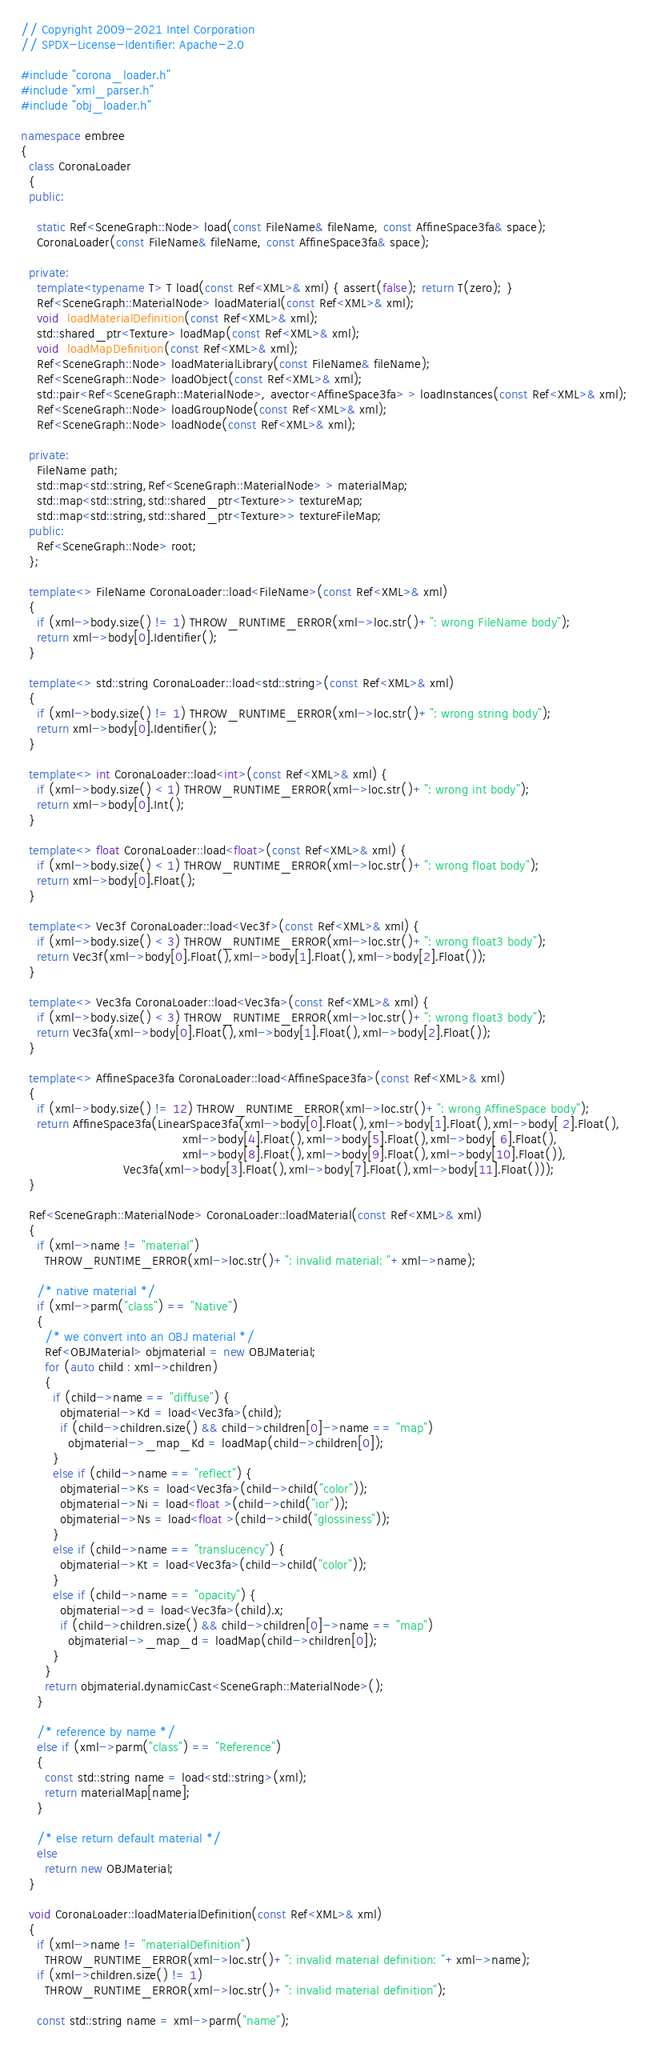<code> <loc_0><loc_0><loc_500><loc_500><_C++_>// Copyright 2009-2021 Intel Corporation
// SPDX-License-Identifier: Apache-2.0

#include "corona_loader.h"
#include "xml_parser.h"
#include "obj_loader.h"

namespace embree
{
  class CoronaLoader
  {
  public:

    static Ref<SceneGraph::Node> load(const FileName& fileName, const AffineSpace3fa& space);
    CoronaLoader(const FileName& fileName, const AffineSpace3fa& space);

  private:
    template<typename T> T load(const Ref<XML>& xml) { assert(false); return T(zero); }
    Ref<SceneGraph::MaterialNode> loadMaterial(const Ref<XML>& xml);
    void  loadMaterialDefinition(const Ref<XML>& xml);
    std::shared_ptr<Texture> loadMap(const Ref<XML>& xml);
    void  loadMapDefinition(const Ref<XML>& xml);
    Ref<SceneGraph::Node> loadMaterialLibrary(const FileName& fileName);
    Ref<SceneGraph::Node> loadObject(const Ref<XML>& xml);
    std::pair<Ref<SceneGraph::MaterialNode>, avector<AffineSpace3fa> > loadInstances(const Ref<XML>& xml);
    Ref<SceneGraph::Node> loadGroupNode(const Ref<XML>& xml);
    Ref<SceneGraph::Node> loadNode(const Ref<XML>& xml);

  private:
    FileName path; 
    std::map<std::string,Ref<SceneGraph::MaterialNode> > materialMap; 
    std::map<std::string,std::shared_ptr<Texture>> textureMap; 
    std::map<std::string,std::shared_ptr<Texture>> textureFileMap; 
  public:
    Ref<SceneGraph::Node> root;
  };

  template<> FileName CoronaLoader::load<FileName>(const Ref<XML>& xml) 
  {
    if (xml->body.size() != 1) THROW_RUNTIME_ERROR(xml->loc.str()+": wrong FileName body");
    return xml->body[0].Identifier();
  }

  template<> std::string CoronaLoader::load<std::string>(const Ref<XML>& xml) 
  {
    if (xml->body.size() != 1) THROW_RUNTIME_ERROR(xml->loc.str()+": wrong string body");
    return xml->body[0].Identifier();
  }

  template<> int CoronaLoader::load<int>(const Ref<XML>& xml) {
    if (xml->body.size() < 1) THROW_RUNTIME_ERROR(xml->loc.str()+": wrong int body");
    return xml->body[0].Int();
  }

  template<> float CoronaLoader::load<float>(const Ref<XML>& xml) {
    if (xml->body.size() < 1) THROW_RUNTIME_ERROR(xml->loc.str()+": wrong float body");
    return xml->body[0].Float();
  }

  template<> Vec3f CoronaLoader::load<Vec3f>(const Ref<XML>& xml) {
    if (xml->body.size() < 3) THROW_RUNTIME_ERROR(xml->loc.str()+": wrong float3 body");
    return Vec3f(xml->body[0].Float(),xml->body[1].Float(),xml->body[2].Float());
  }

  template<> Vec3fa CoronaLoader::load<Vec3fa>(const Ref<XML>& xml) {
    if (xml->body.size() < 3) THROW_RUNTIME_ERROR(xml->loc.str()+": wrong float3 body");
    return Vec3fa(xml->body[0].Float(),xml->body[1].Float(),xml->body[2].Float());
  }

  template<> AffineSpace3fa CoronaLoader::load<AffineSpace3fa>(const Ref<XML>& xml) 
  {
    if (xml->body.size() != 12) THROW_RUNTIME_ERROR(xml->loc.str()+": wrong AffineSpace body");
    return AffineSpace3fa(LinearSpace3fa(xml->body[0].Float(),xml->body[1].Float(),xml->body[ 2].Float(),
                                         xml->body[4].Float(),xml->body[5].Float(),xml->body[ 6].Float(),
                                         xml->body[8].Float(),xml->body[9].Float(),xml->body[10].Float()),
                          Vec3fa(xml->body[3].Float(),xml->body[7].Float(),xml->body[11].Float()));
  }

  Ref<SceneGraph::MaterialNode> CoronaLoader::loadMaterial(const Ref<XML>& xml) 
  {
    if (xml->name != "material") 
      THROW_RUNTIME_ERROR(xml->loc.str()+": invalid material: "+xml->name);

    /* native material */
    if (xml->parm("class") == "Native") 
    {
      /* we convert into an OBJ material */
      Ref<OBJMaterial> objmaterial = new OBJMaterial;
      for (auto child : xml->children)
      {
        if (child->name == "diffuse") {
          objmaterial->Kd = load<Vec3fa>(child);
          if (child->children.size() && child->children[0]->name == "map")
            objmaterial->_map_Kd = loadMap(child->children[0]);
        }
        else if (child->name == "reflect") {
          objmaterial->Ks = load<Vec3fa>(child->child("color"));
          objmaterial->Ni = load<float >(child->child("ior"));
          objmaterial->Ns = load<float >(child->child("glossiness"));
        }
        else if (child->name == "translucency") {
          objmaterial->Kt = load<Vec3fa>(child->child("color"));
        }
        else if (child->name == "opacity") {
          objmaterial->d = load<Vec3fa>(child).x;
          if (child->children.size() && child->children[0]->name == "map")
            objmaterial->_map_d = loadMap(child->children[0]);
        }
      }
      return objmaterial.dynamicCast<SceneGraph::MaterialNode>();
    }

    /* reference by name */
    else if (xml->parm("class") == "Reference") 
    {
      const std::string name = load<std::string>(xml);
      return materialMap[name];
    }

    /* else return default material */
    else 
      return new OBJMaterial;
  }

  void CoronaLoader::loadMaterialDefinition(const Ref<XML>& xml) 
  {
    if (xml->name != "materialDefinition") 
      THROW_RUNTIME_ERROR(xml->loc.str()+": invalid material definition: "+xml->name);
    if (xml->children.size() != 1) 
      THROW_RUNTIME_ERROR(xml->loc.str()+": invalid material definition");

    const std::string name = xml->parm("name");</code> 